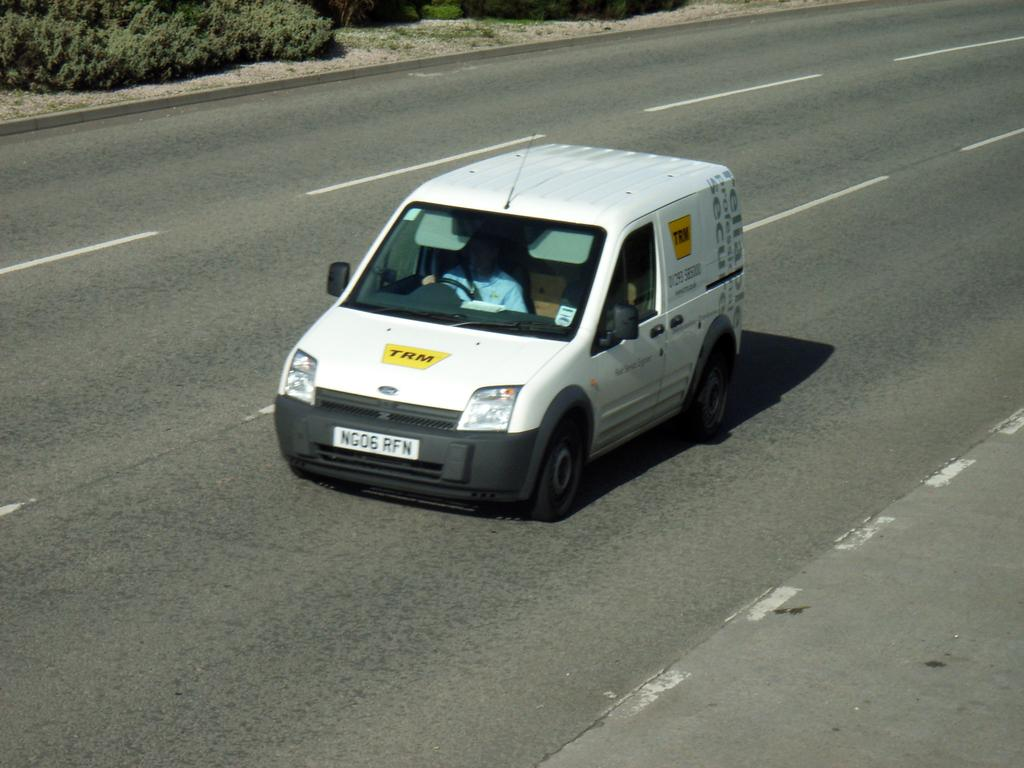What is on the road in the image? There is a vehicle on the road in the image. Who is inside the vehicle? A person is sitting in the vehicle. What can be seen in the background of the image? There are plants visible in the background of the image. Where are the plants located in relation to the ground? The plants are on the ground. Can you see an owl perched on the person's shoulder in the image? No, there is no owl present in the image. 